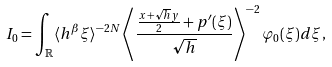<formula> <loc_0><loc_0><loc_500><loc_500>I _ { 0 } = \int _ { \mathbb { R } } \langle h ^ { \beta } \xi \rangle ^ { - 2 N } \left \langle \frac { \frac { x + \sqrt { h } y } { 2 } + p ^ { \prime } ( \xi ) } { \sqrt { h } } \right \rangle ^ { - 2 } \varphi _ { 0 } ( \xi ) d \xi \, ,</formula> 